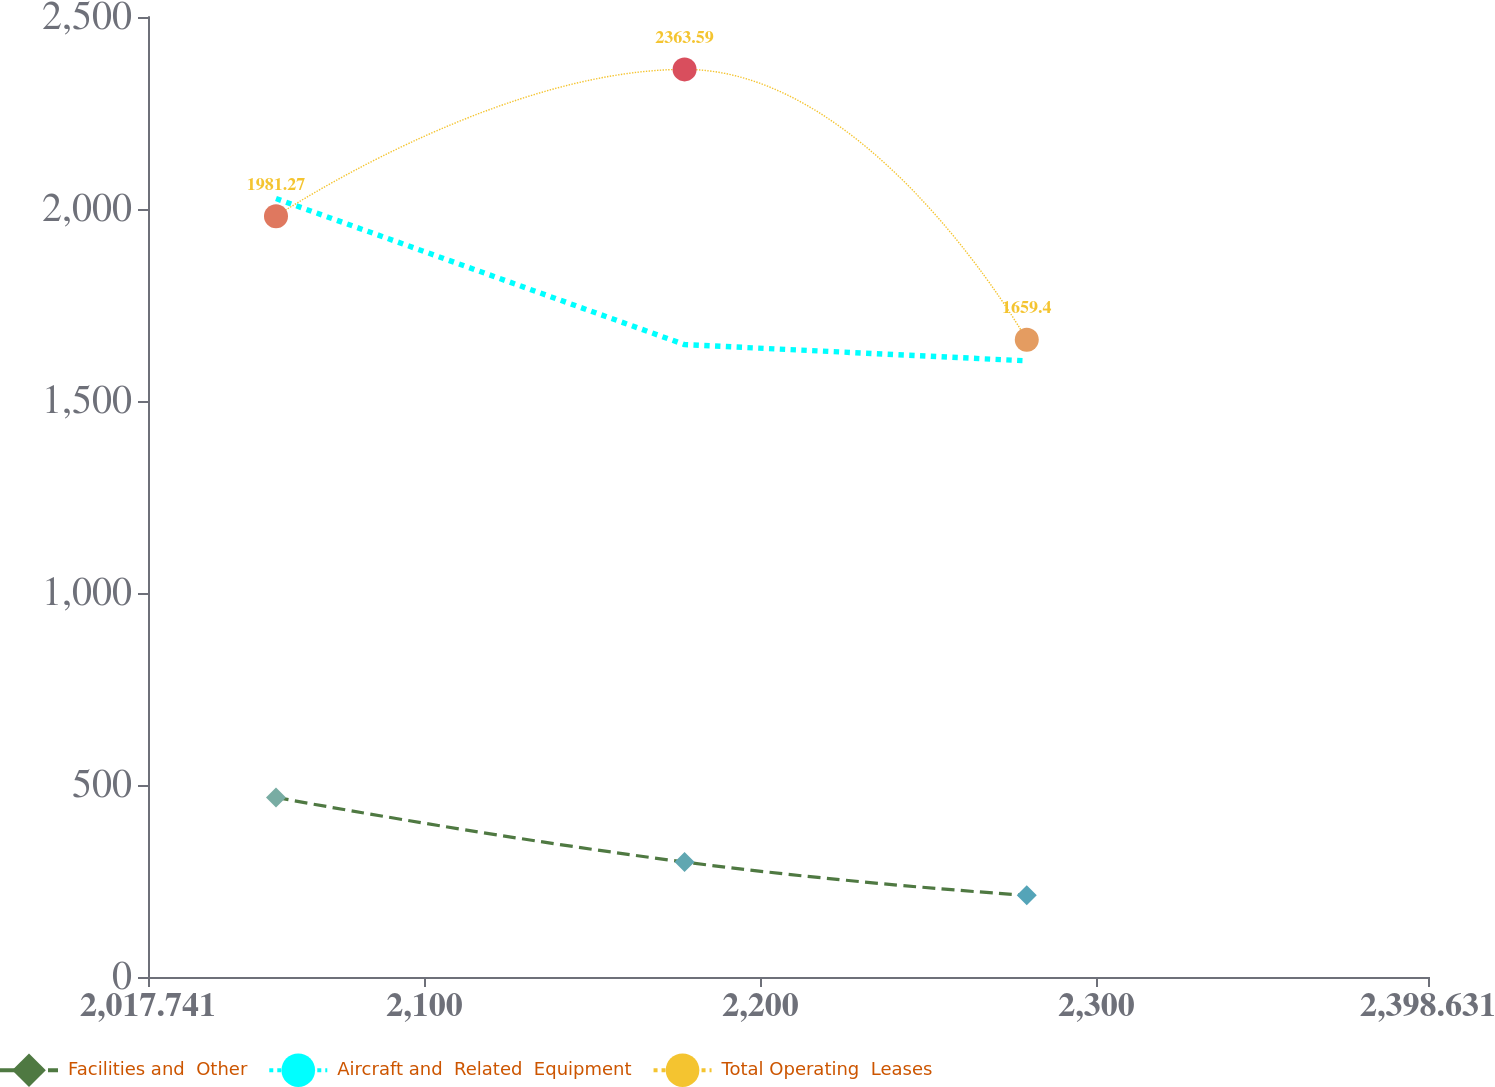Convert chart. <chart><loc_0><loc_0><loc_500><loc_500><line_chart><ecel><fcel>Facilities and  Other<fcel>Aircraft and  Related  Equipment<fcel>Total Operating  Leases<nl><fcel>2055.83<fcel>467.7<fcel>2027.25<fcel>1981.27<nl><fcel>2177.41<fcel>299.37<fcel>1646.89<fcel>2363.59<nl><fcel>2279.24<fcel>212.64<fcel>1604.63<fcel>1659.4<nl><fcel>2400.16<fcel>240.98<fcel>1731.41<fcel>2065.89<nl><fcel>2436.72<fcel>184.3<fcel>1689.15<fcel>1517.4<nl></chart> 